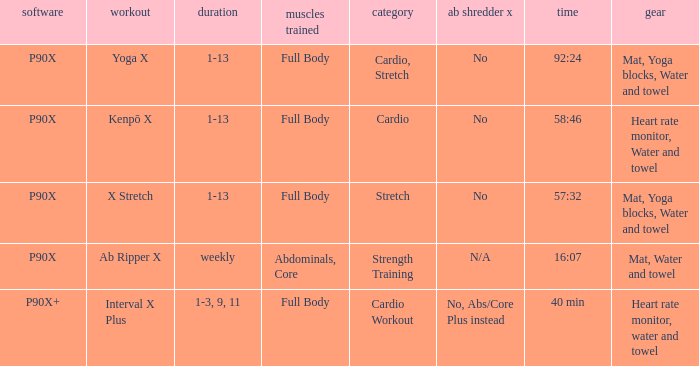What is the exercise when the equipment is heart rate monitor, water and towel? Kenpō X, Interval X Plus. 